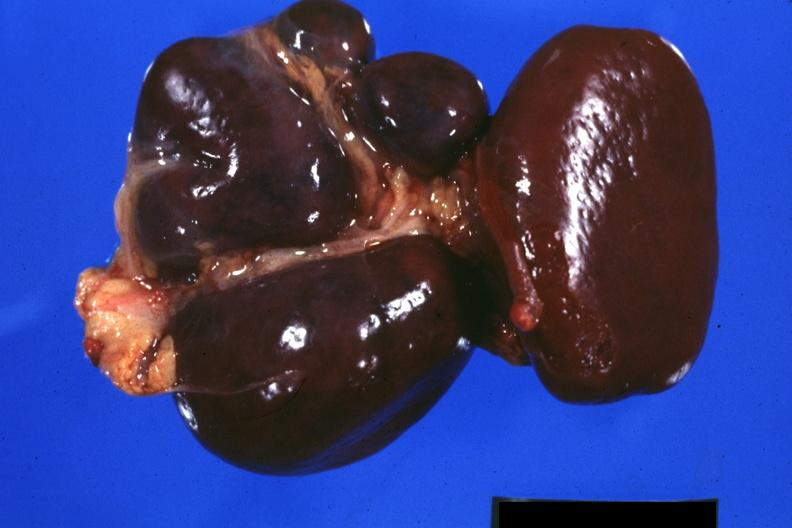what is present?
Answer the question using a single word or phrase. Hematologic 